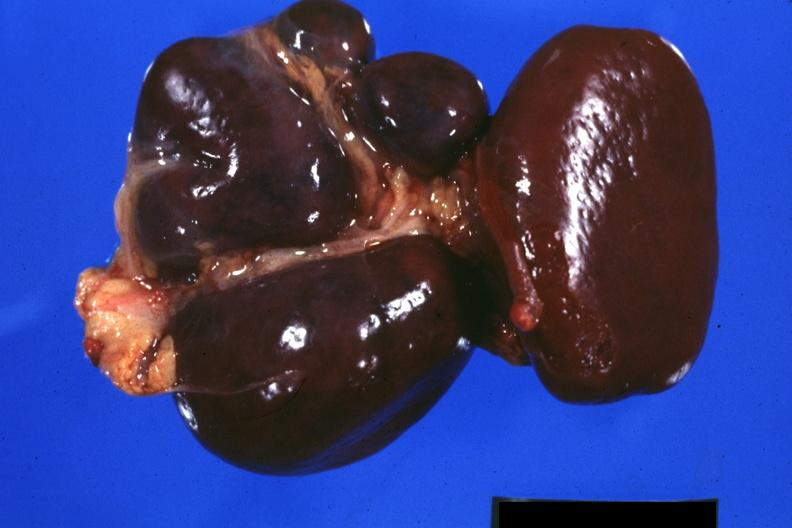what is present?
Answer the question using a single word or phrase. Hematologic 